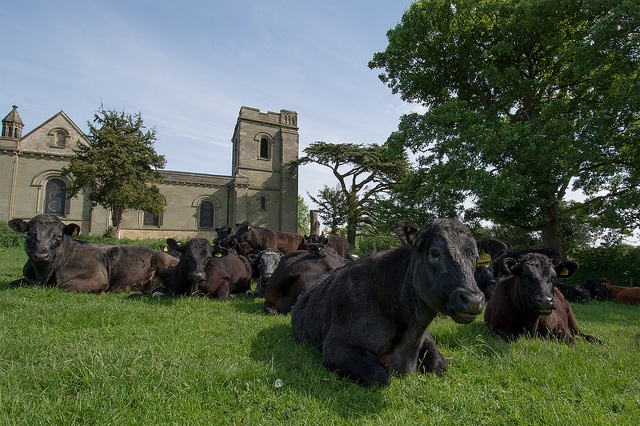Describe the objects in this image and their specific colors. I can see cow in darkgray, black, gray, and darkgreen tones, cow in darkgray, black, and gray tones, cow in darkgray, black, gray, darkgreen, and maroon tones, cow in darkgray, black, and gray tones, and cow in darkgray, black, and gray tones in this image. 